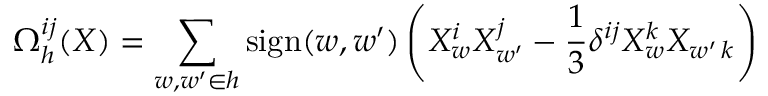<formula> <loc_0><loc_0><loc_500><loc_500>\Omega _ { h } ^ { i j } ( X ) = \sum _ { w , { w ^ { \prime } } \in h } s i g n ( w , { w ^ { \prime } } ) \left ( X _ { w } ^ { i } X _ { w ^ { \prime } } ^ { j } - { \frac { 1 } { 3 } } \delta ^ { i j } X _ { w } ^ { k } X _ { w ^ { \prime } \, k } \right )</formula> 